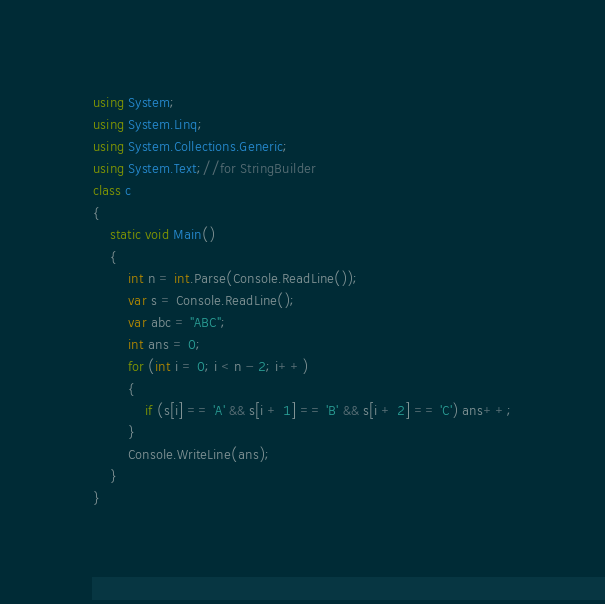<code> <loc_0><loc_0><loc_500><loc_500><_C#_>using System;
using System.Linq;
using System.Collections.Generic;
using System.Text;//for StringBuilder
class c
{
    static void Main()
    {
        int n = int.Parse(Console.ReadLine());
        var s = Console.ReadLine();
        var abc = "ABC";
        int ans = 0;
        for (int i = 0; i < n - 2; i++)
        {
            if (s[i] == 'A' && s[i + 1] == 'B' && s[i + 2] == 'C') ans++;
        }
        Console.WriteLine(ans);
    }
}</code> 